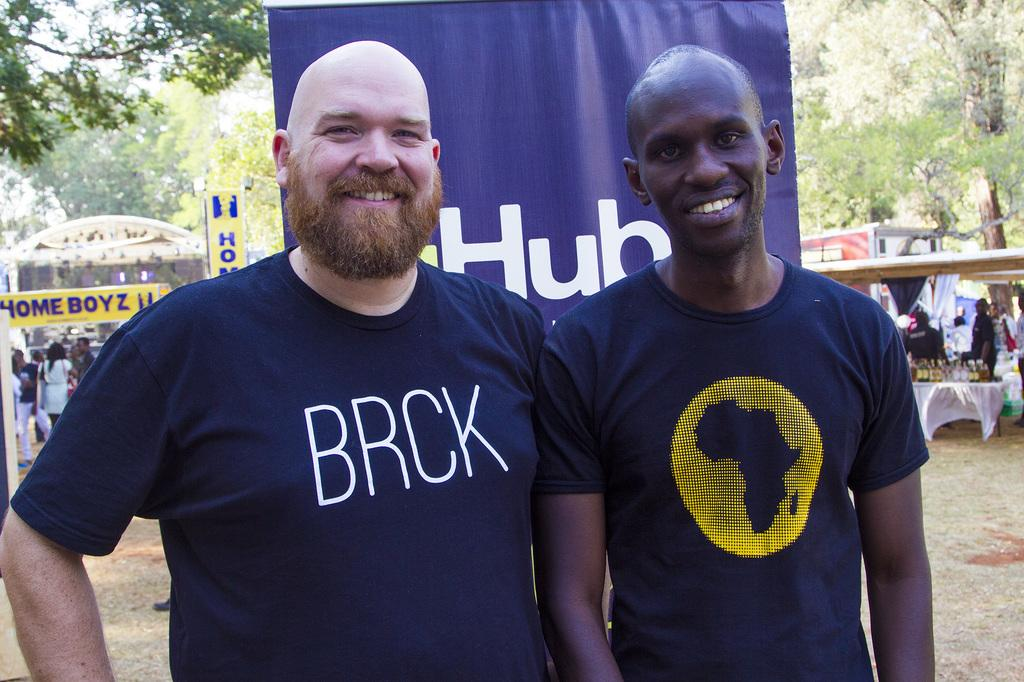How many men are present in the image? There are two men in the image. Where are the men positioned in the image? The men are standing in the front. What are the men wearing in the image? Both men are wearing blue t-shirts. What is the facial expression of the men in the image? The men are smiling. What are the men doing in the image? The men are giving a pose into the camera. What is the chance of rain in the image? There is no information about the weather or chance of rain in the image. What adjustment needs to be made to the camera in the image? There is no indication that any adjustment needs to be made to the camera in the image. 